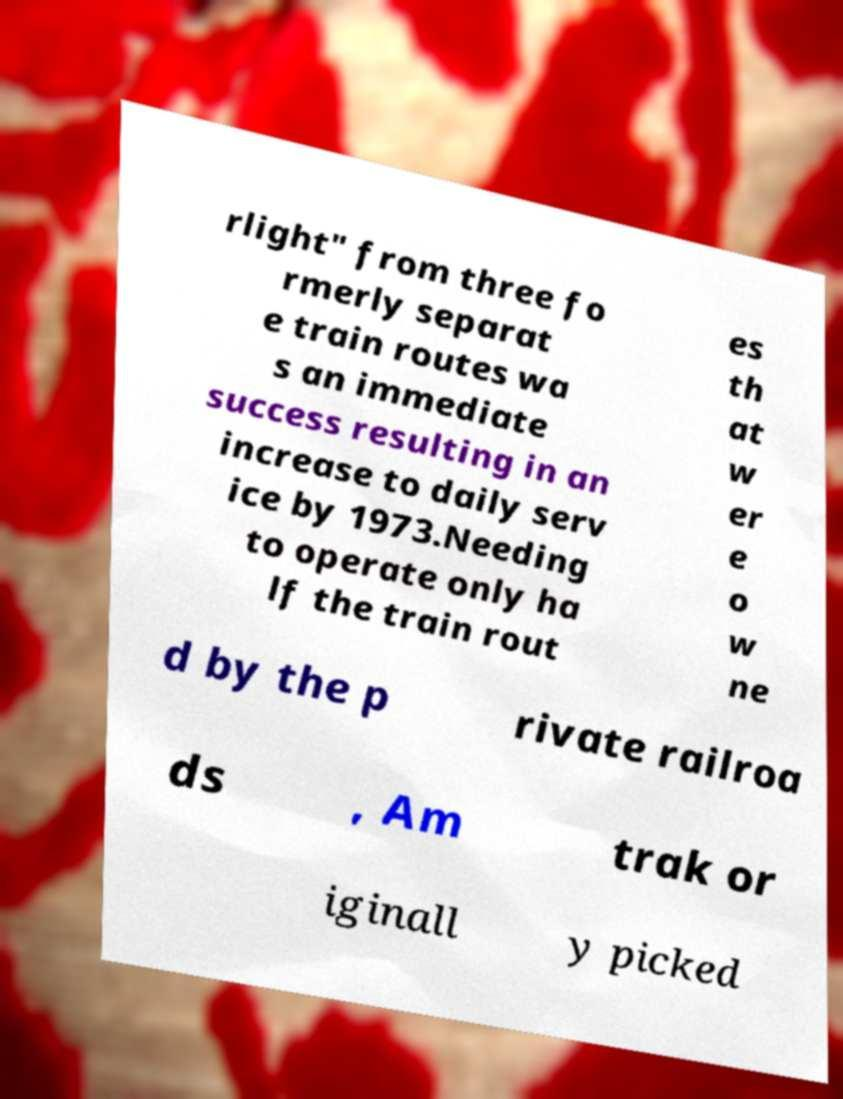Please read and relay the text visible in this image. What does it say? rlight" from three fo rmerly separat e train routes wa s an immediate success resulting in an increase to daily serv ice by 1973.Needing to operate only ha lf the train rout es th at w er e o w ne d by the p rivate railroa ds , Am trak or iginall y picked 